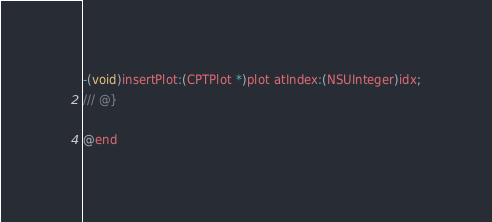Convert code to text. <code><loc_0><loc_0><loc_500><loc_500><_C_>-(void)insertPlot:(CPTPlot *)plot atIndex:(NSUInteger)idx;
/// @}

@end
</code> 